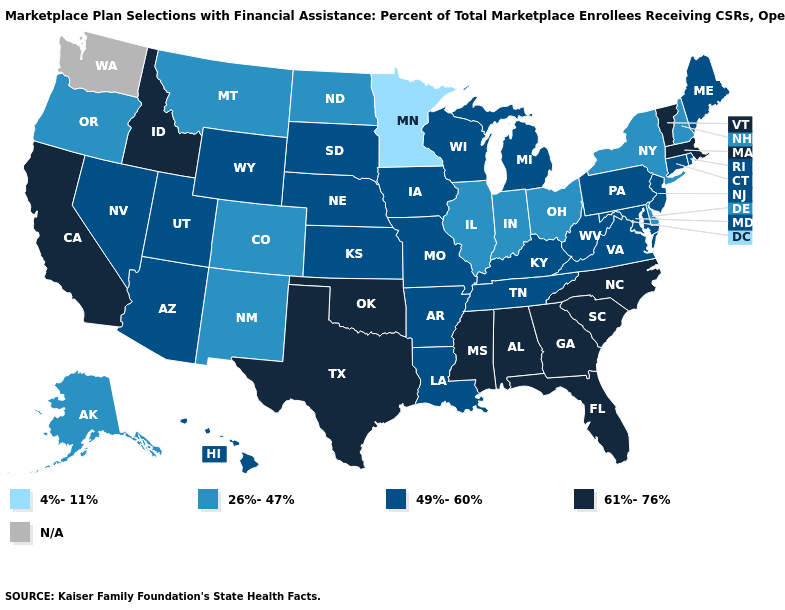Name the states that have a value in the range 49%-60%?
Keep it brief. Arizona, Arkansas, Connecticut, Hawaii, Iowa, Kansas, Kentucky, Louisiana, Maine, Maryland, Michigan, Missouri, Nebraska, Nevada, New Jersey, Pennsylvania, Rhode Island, South Dakota, Tennessee, Utah, Virginia, West Virginia, Wisconsin, Wyoming. Name the states that have a value in the range 49%-60%?
Write a very short answer. Arizona, Arkansas, Connecticut, Hawaii, Iowa, Kansas, Kentucky, Louisiana, Maine, Maryland, Michigan, Missouri, Nebraska, Nevada, New Jersey, Pennsylvania, Rhode Island, South Dakota, Tennessee, Utah, Virginia, West Virginia, Wisconsin, Wyoming. Does Montana have the highest value in the USA?
Concise answer only. No. Name the states that have a value in the range 61%-76%?
Answer briefly. Alabama, California, Florida, Georgia, Idaho, Massachusetts, Mississippi, North Carolina, Oklahoma, South Carolina, Texas, Vermont. What is the value of Kentucky?
Quick response, please. 49%-60%. What is the lowest value in states that border South Carolina?
Concise answer only. 61%-76%. What is the highest value in states that border Arkansas?
Concise answer only. 61%-76%. Name the states that have a value in the range 26%-47%?
Answer briefly. Alaska, Colorado, Delaware, Illinois, Indiana, Montana, New Hampshire, New Mexico, New York, North Dakota, Ohio, Oregon. Does Wyoming have the highest value in the West?
Concise answer only. No. Among the states that border Arkansas , does Louisiana have the lowest value?
Give a very brief answer. Yes. What is the value of California?
Keep it brief. 61%-76%. Among the states that border New Mexico , which have the lowest value?
Short answer required. Colorado. What is the value of Delaware?
Quick response, please. 26%-47%. What is the lowest value in the West?
Quick response, please. 26%-47%. 